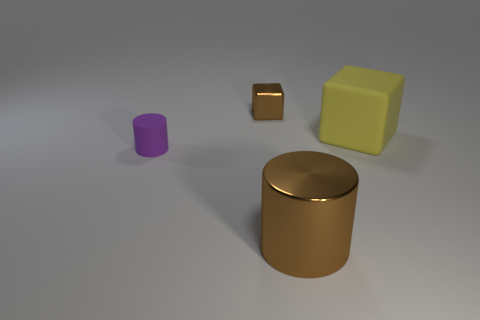Add 4 red blocks. How many objects exist? 8 Add 3 brown metal cylinders. How many brown metal cylinders are left? 4 Add 4 big yellow metallic balls. How many big yellow metallic balls exist? 4 Subtract 0 red cylinders. How many objects are left? 4 Subtract all small rubber objects. Subtract all tiny cubes. How many objects are left? 2 